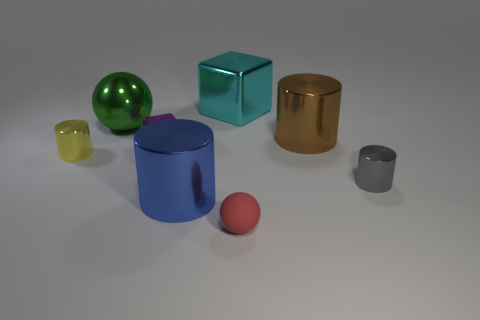There is a thing that is on the left side of the brown cylinder and right of the large cyan cube; what shape is it?
Your answer should be compact. Sphere. What is the size of the brown metal object that is the same shape as the small gray object?
Offer a very short reply. Large. Is the shape of the large cyan object the same as the yellow thing?
Your answer should be compact. No. What is the size of the shiny block that is behind the block that is in front of the large brown shiny cylinder?
Provide a short and direct response. Large. There is another thing that is the same shape as the cyan thing; what is its color?
Your answer should be compact. Purple. What is the size of the brown metallic object?
Provide a succinct answer. Large. Does the gray object have the same size as the brown shiny thing?
Ensure brevity in your answer.  No. What is the color of the metal cylinder that is on the left side of the gray cylinder and in front of the yellow shiny cylinder?
Make the answer very short. Blue. There is a purple metal thing; is it the same size as the sphere in front of the yellow shiny cylinder?
Provide a succinct answer. Yes. What is the material of the ball behind the metal cylinder on the left side of the large green metal thing?
Your answer should be compact. Metal. 